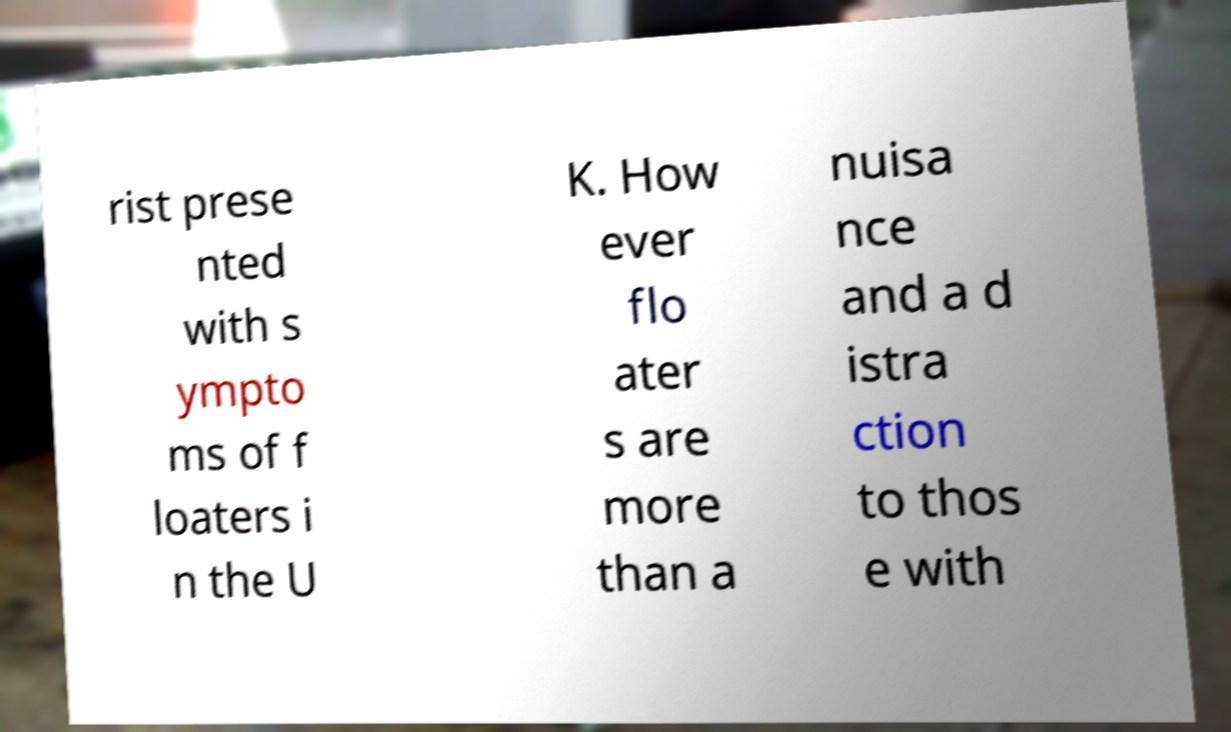There's text embedded in this image that I need extracted. Can you transcribe it verbatim? rist prese nted with s ympto ms of f loaters i n the U K. How ever flo ater s are more than a nuisa nce and a d istra ction to thos e with 